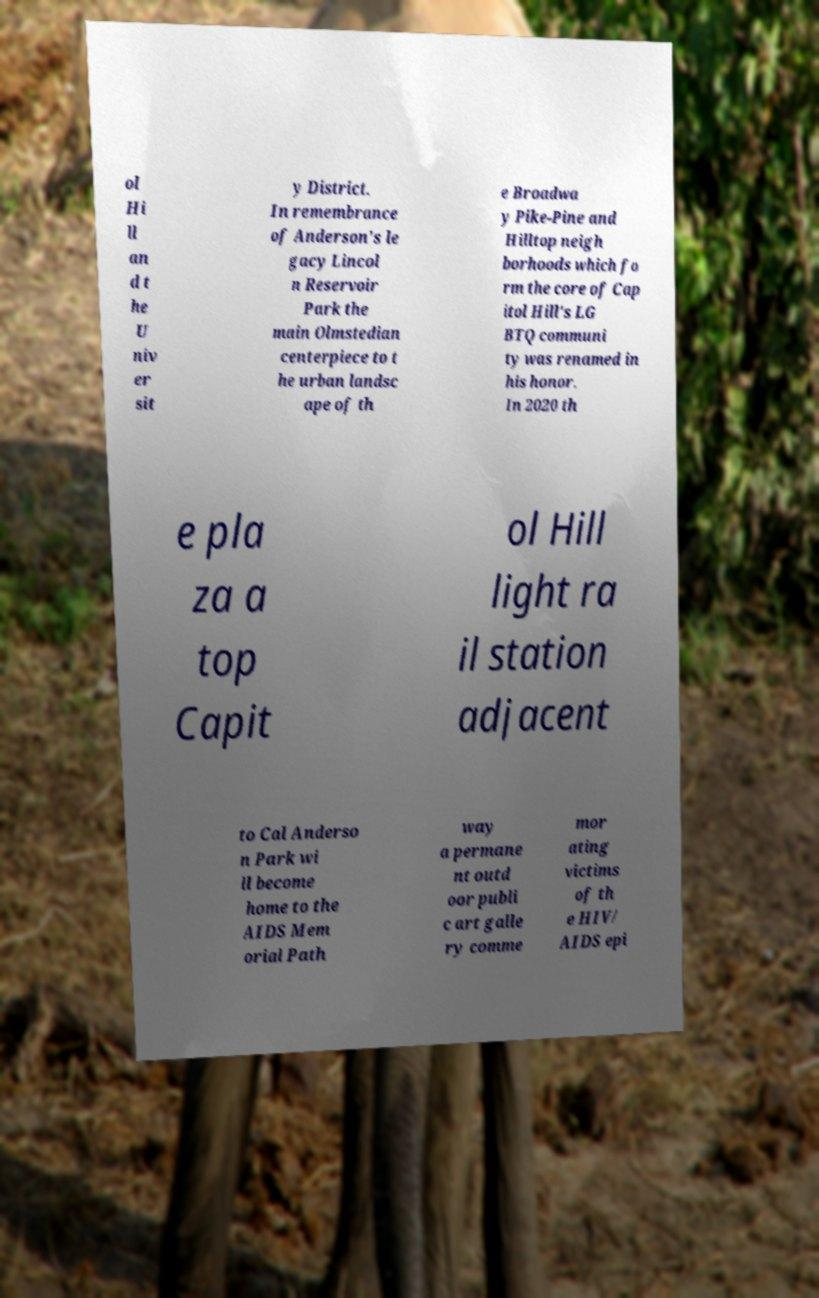Can you accurately transcribe the text from the provided image for me? ol Hi ll an d t he U niv er sit y District. In remembrance of Anderson's le gacy Lincol n Reservoir Park the main Olmstedian centerpiece to t he urban landsc ape of th e Broadwa y Pike-Pine and Hilltop neigh borhoods which fo rm the core of Cap itol Hill's LG BTQ communi ty was renamed in his honor. In 2020 th e pla za a top Capit ol Hill light ra il station adjacent to Cal Anderso n Park wi ll become home to the AIDS Mem orial Path way a permane nt outd oor publi c art galle ry comme mor ating victims of th e HIV/ AIDS epi 